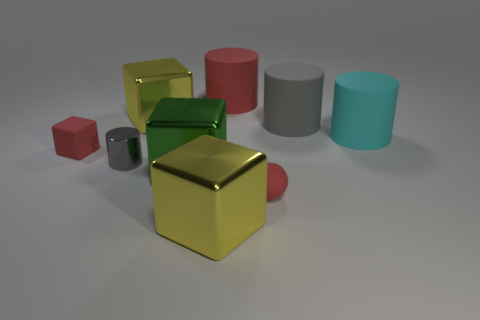Subtract all red cylinders. How many cylinders are left? 3 Subtract all cyan balls. How many gray cylinders are left? 2 Subtract 2 cylinders. How many cylinders are left? 2 Add 1 big blocks. How many objects exist? 10 Subtract all red cubes. How many cubes are left? 3 Subtract all gray cubes. Subtract all red balls. How many cubes are left? 4 Add 8 gray matte cylinders. How many gray matte cylinders exist? 9 Subtract 0 purple balls. How many objects are left? 9 Subtract all cubes. How many objects are left? 5 Subtract all tiny yellow blocks. Subtract all tiny red spheres. How many objects are left? 8 